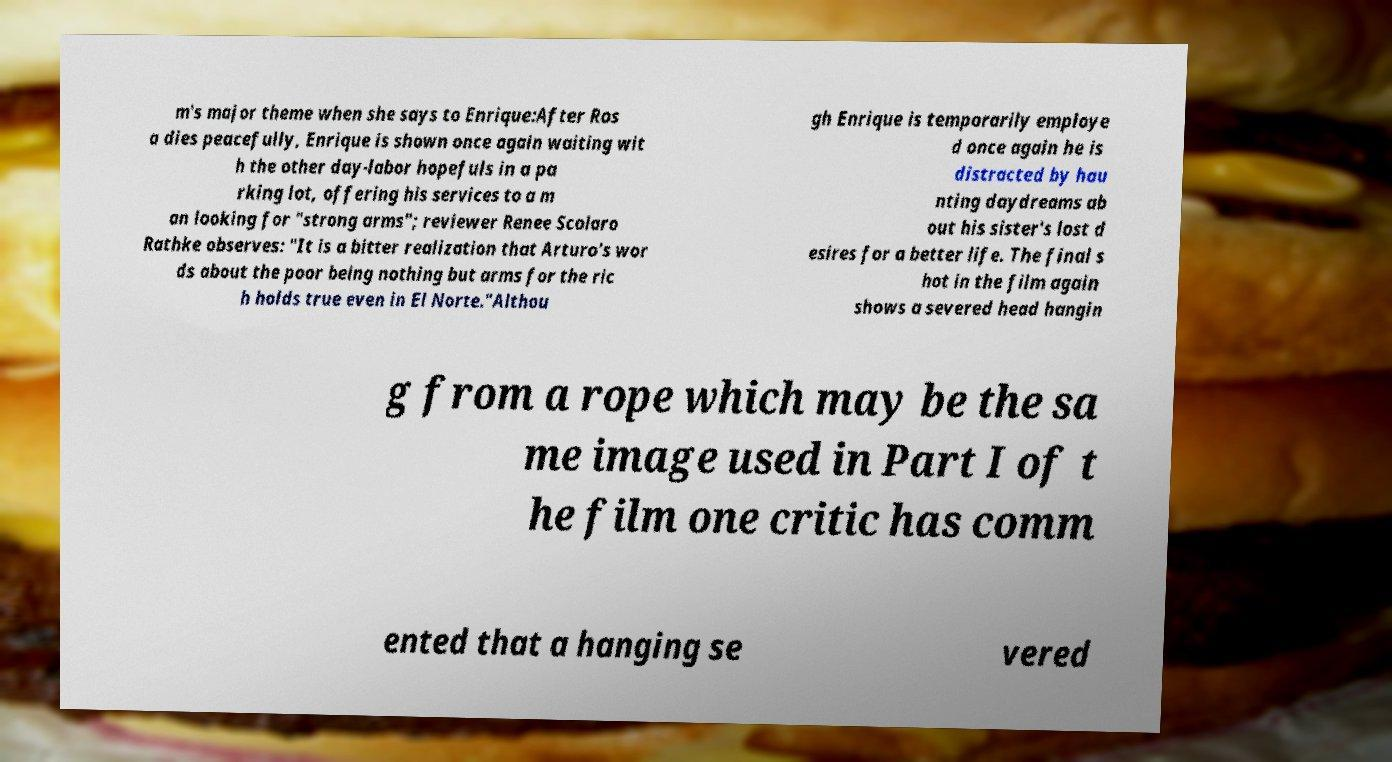Could you extract and type out the text from this image? m's major theme when she says to Enrique:After Ros a dies peacefully, Enrique is shown once again waiting wit h the other day-labor hopefuls in a pa rking lot, offering his services to a m an looking for "strong arms"; reviewer Renee Scolaro Rathke observes: "It is a bitter realization that Arturo's wor ds about the poor being nothing but arms for the ric h holds true even in El Norte."Althou gh Enrique is temporarily employe d once again he is distracted by hau nting daydreams ab out his sister's lost d esires for a better life. The final s hot in the film again shows a severed head hangin g from a rope which may be the sa me image used in Part I of t he film one critic has comm ented that a hanging se vered 